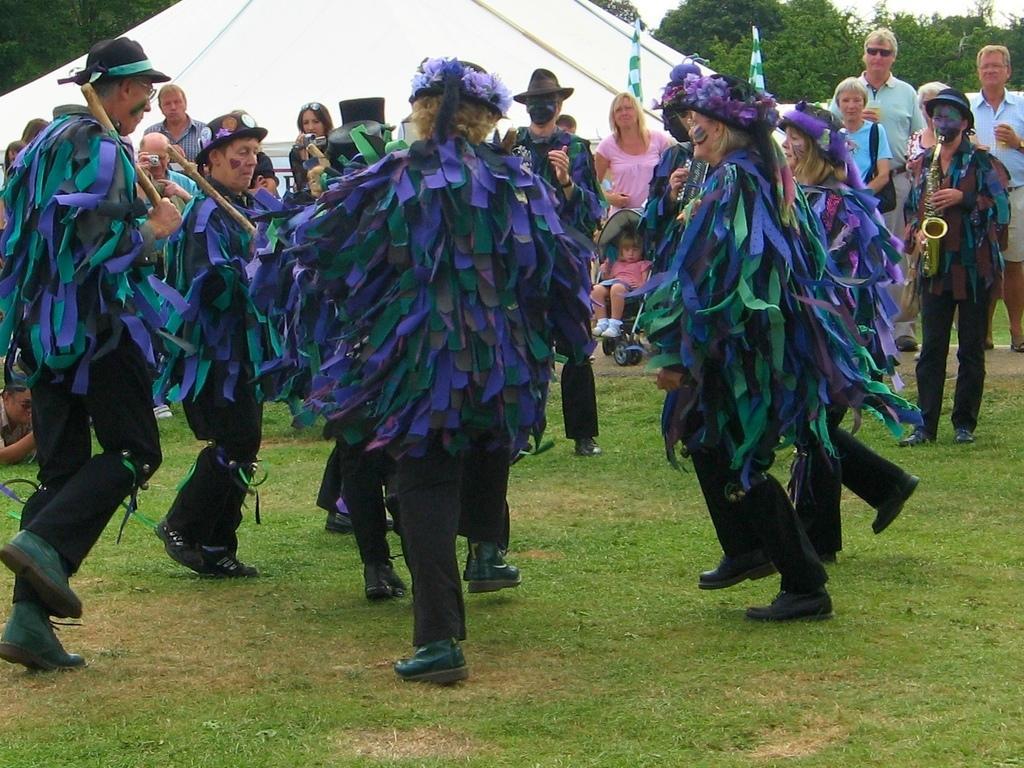How would you summarize this image in a sentence or two? There are people dancing and wore fancy dresses and this person standing and playing musical instrument and we can see grass. In the background we can see tent,people,trees and sky. 